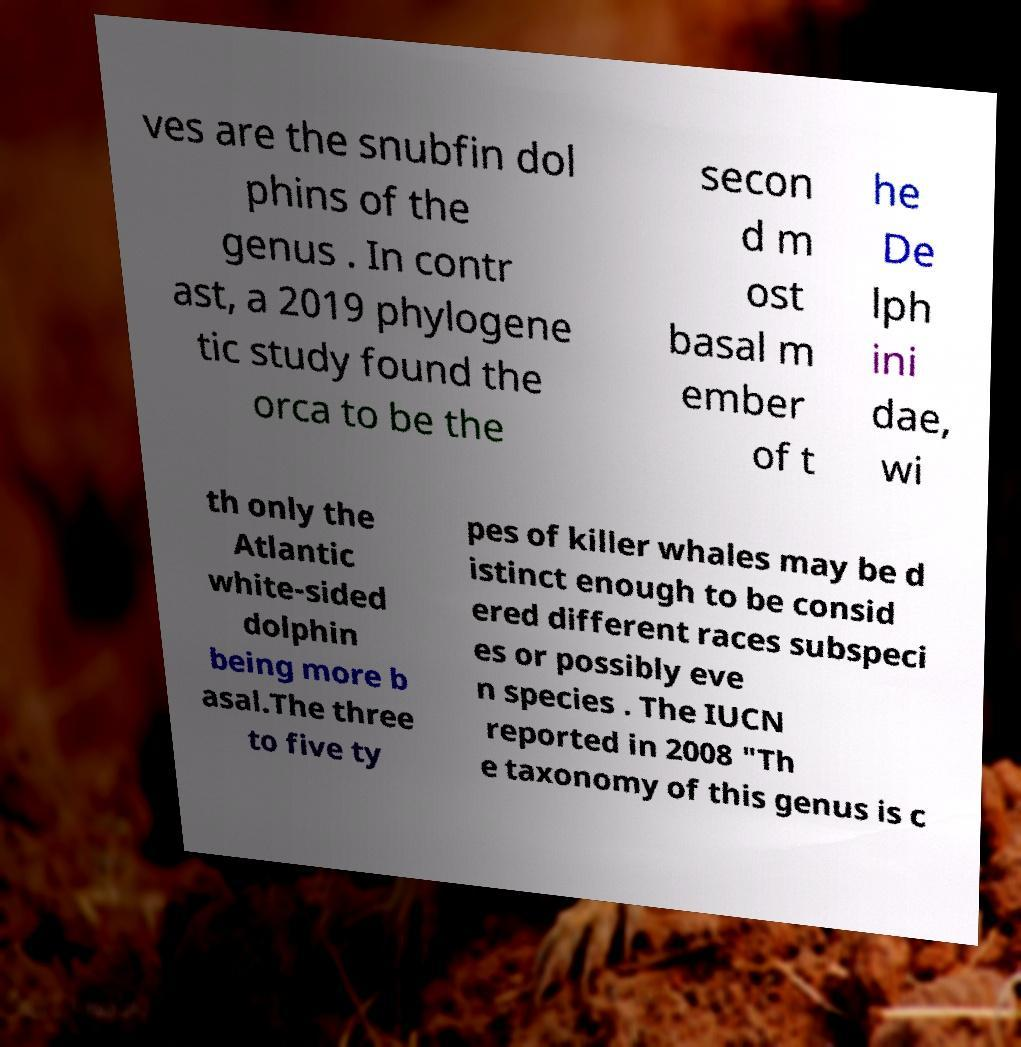Please read and relay the text visible in this image. What does it say? ves are the snubfin dol phins of the genus . In contr ast, a 2019 phylogene tic study found the orca to be the secon d m ost basal m ember of t he De lph ini dae, wi th only the Atlantic white-sided dolphin being more b asal.The three to five ty pes of killer whales may be d istinct enough to be consid ered different races subspeci es or possibly eve n species . The IUCN reported in 2008 "Th e taxonomy of this genus is c 